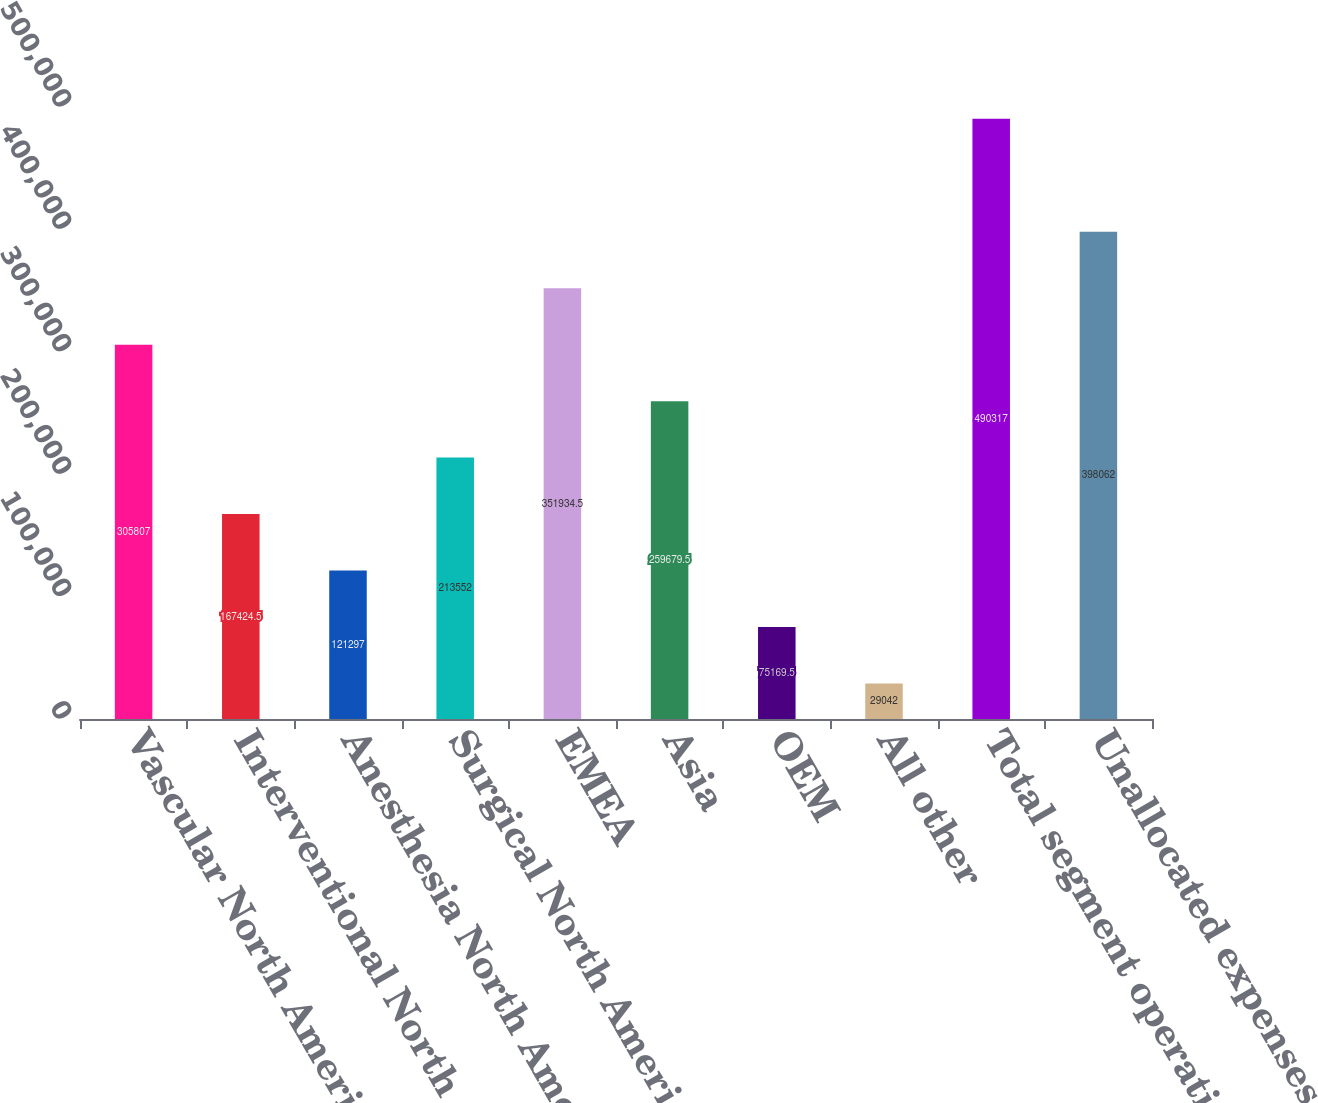Convert chart. <chart><loc_0><loc_0><loc_500><loc_500><bar_chart><fcel>Vascular North America<fcel>Interventional North America<fcel>Anesthesia North America<fcel>Surgical North America<fcel>EMEA<fcel>Asia<fcel>OEM<fcel>All other<fcel>Total segment operating profit<fcel>Unallocated expenses (2)<nl><fcel>305807<fcel>167424<fcel>121297<fcel>213552<fcel>351934<fcel>259680<fcel>75169.5<fcel>29042<fcel>490317<fcel>398062<nl></chart> 